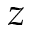<formula> <loc_0><loc_0><loc_500><loc_500>z</formula> 